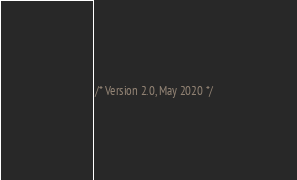Convert code to text. <code><loc_0><loc_0><loc_500><loc_500><_CSS_>/* Version 2.0, May 2020 */
</code> 